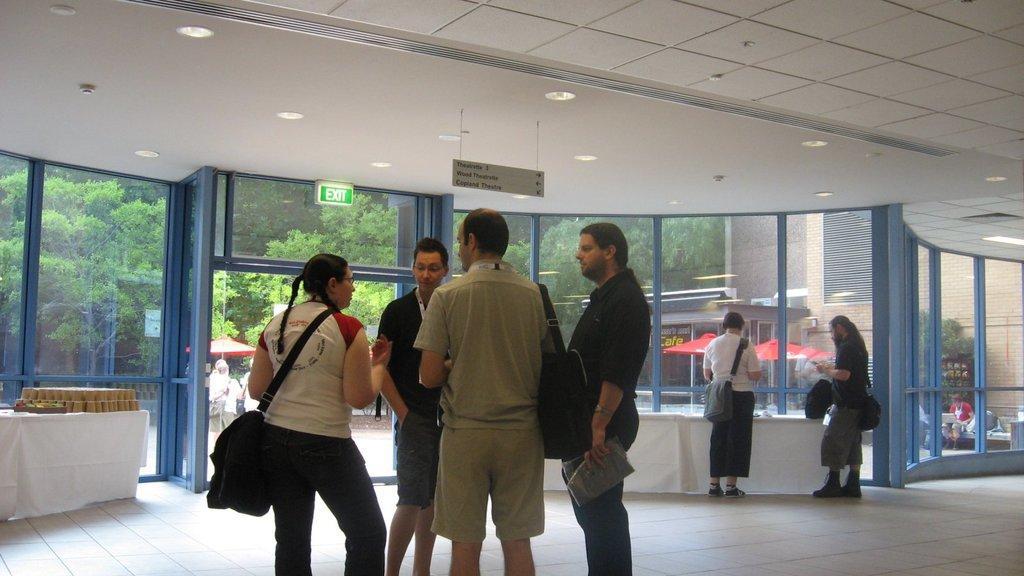How would you summarize this image in a sentence or two? This picture describes about group of people, few are seated and few are standing, on the left side of the image we can see few cups and other things on the table, in the background we can see few tents, trees and buildings. 